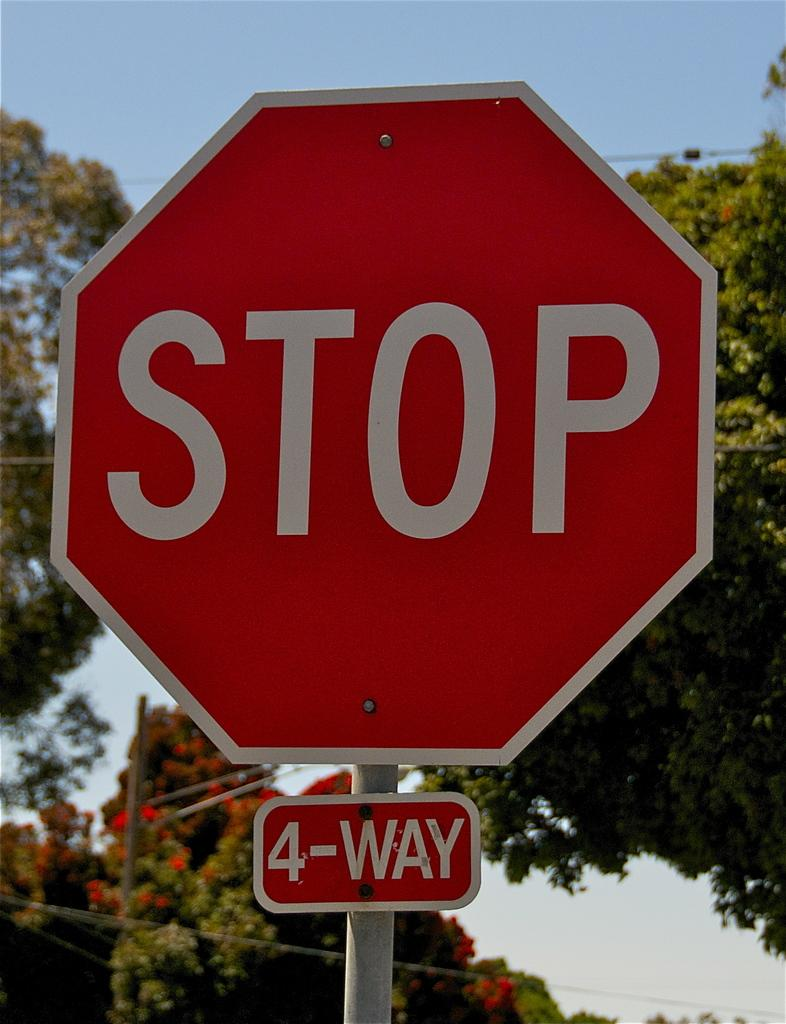<image>
Describe the image concisely. A Stop sign with a 4-Way sign attached to the pole stands in front of trees. 